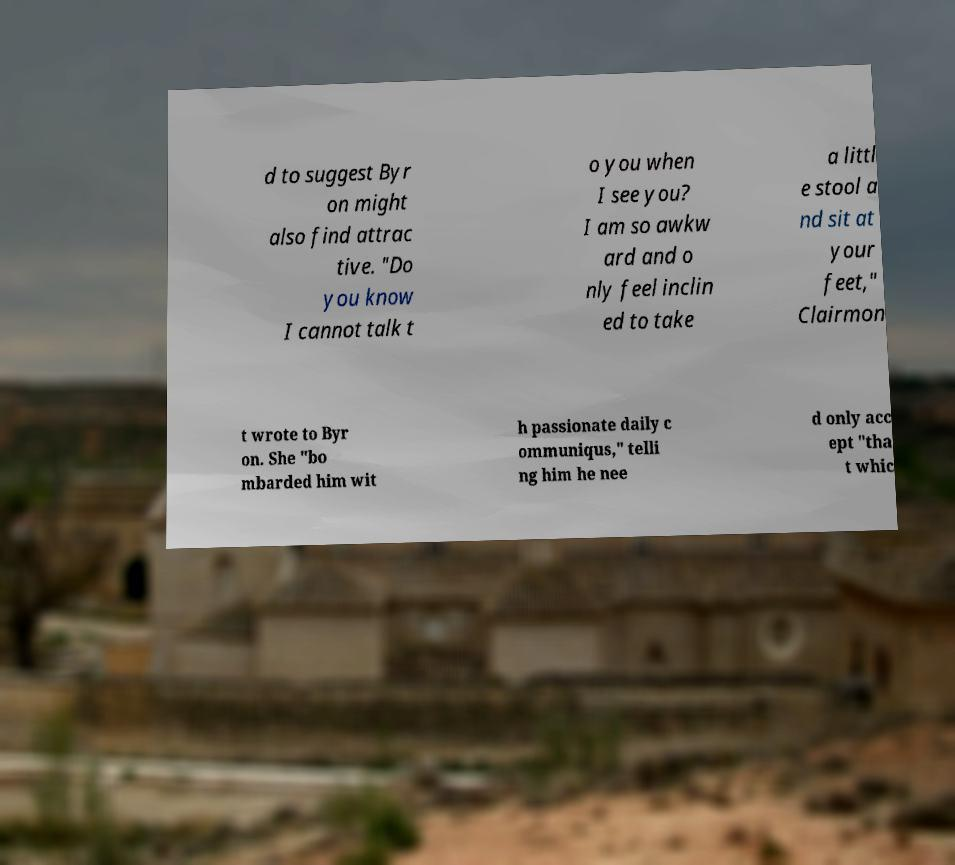Can you accurately transcribe the text from the provided image for me? d to suggest Byr on might also find attrac tive. "Do you know I cannot talk t o you when I see you? I am so awkw ard and o nly feel inclin ed to take a littl e stool a nd sit at your feet," Clairmon t wrote to Byr on. She "bo mbarded him wit h passionate daily c ommuniqus," telli ng him he nee d only acc ept "tha t whic 